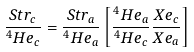<formula> <loc_0><loc_0><loc_500><loc_500>\frac { S t r _ { c } } { ^ { 4 } H e _ { c } } = \frac { S t r _ { a } } { ^ { 4 } H e _ { a } } \left [ \frac { ^ { 4 } H e _ { a } } { ^ { 4 } H e _ { c } } \frac { X e _ { c } } { X e _ { a } } \right ]</formula> 